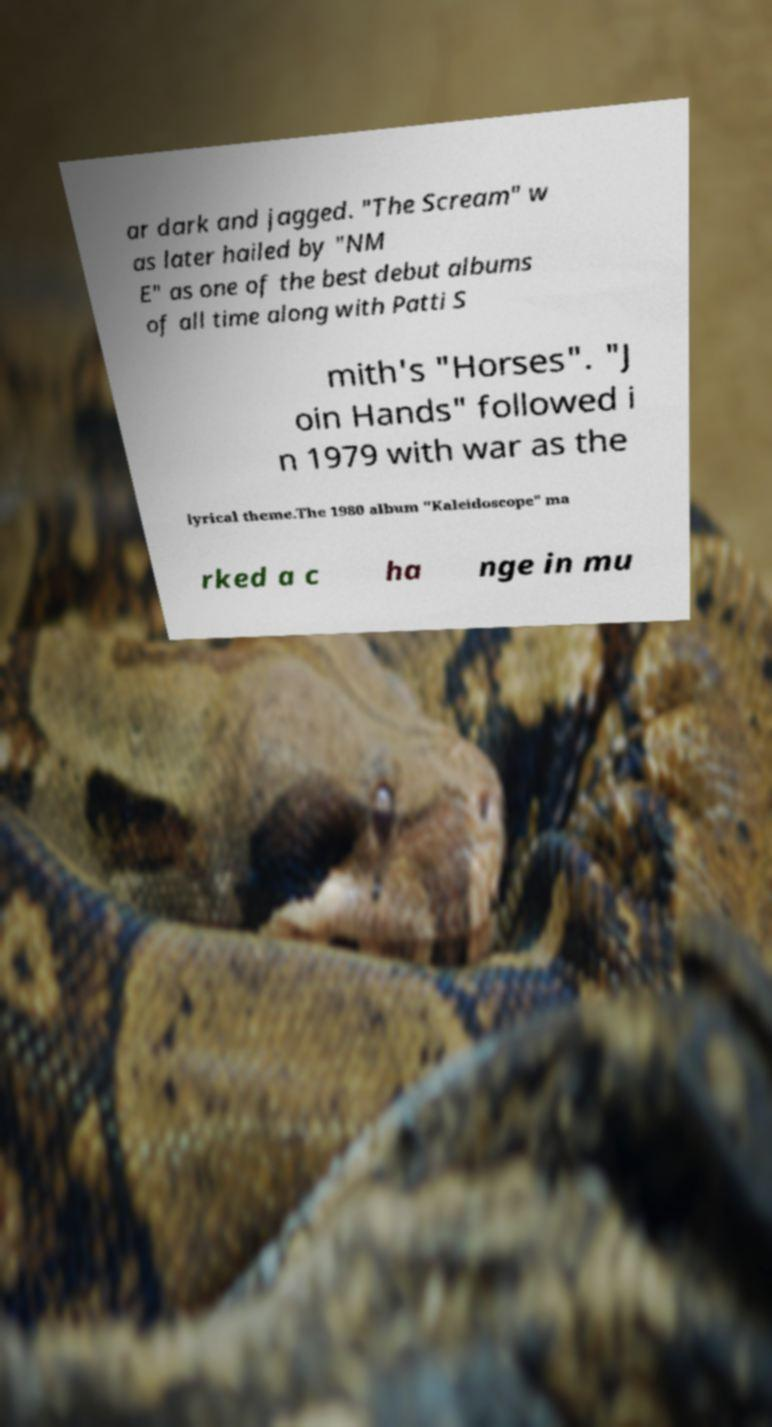What messages or text are displayed in this image? I need them in a readable, typed format. ar dark and jagged. "The Scream" w as later hailed by "NM E" as one of the best debut albums of all time along with Patti S mith's "Horses". "J oin Hands" followed i n 1979 with war as the lyrical theme.The 1980 album "Kaleidoscope" ma rked a c ha nge in mu 